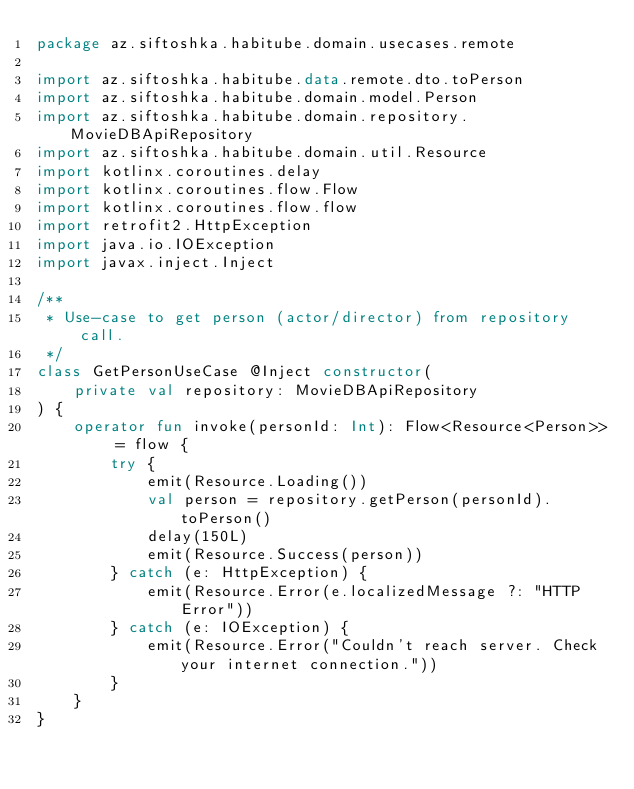Convert code to text. <code><loc_0><loc_0><loc_500><loc_500><_Kotlin_>package az.siftoshka.habitube.domain.usecases.remote

import az.siftoshka.habitube.data.remote.dto.toPerson
import az.siftoshka.habitube.domain.model.Person
import az.siftoshka.habitube.domain.repository.MovieDBApiRepository
import az.siftoshka.habitube.domain.util.Resource
import kotlinx.coroutines.delay
import kotlinx.coroutines.flow.Flow
import kotlinx.coroutines.flow.flow
import retrofit2.HttpException
import java.io.IOException
import javax.inject.Inject

/**
 * Use-case to get person (actor/director) from repository call.
 */
class GetPersonUseCase @Inject constructor(
    private val repository: MovieDBApiRepository
) {
    operator fun invoke(personId: Int): Flow<Resource<Person>> = flow {
        try {
            emit(Resource.Loading())
            val person = repository.getPerson(personId).toPerson()
            delay(150L)
            emit(Resource.Success(person))
        } catch (e: HttpException) {
            emit(Resource.Error(e.localizedMessage ?: "HTTP Error"))
        } catch (e: IOException) {
            emit(Resource.Error("Couldn't reach server. Check your internet connection."))
        }
    }
}</code> 